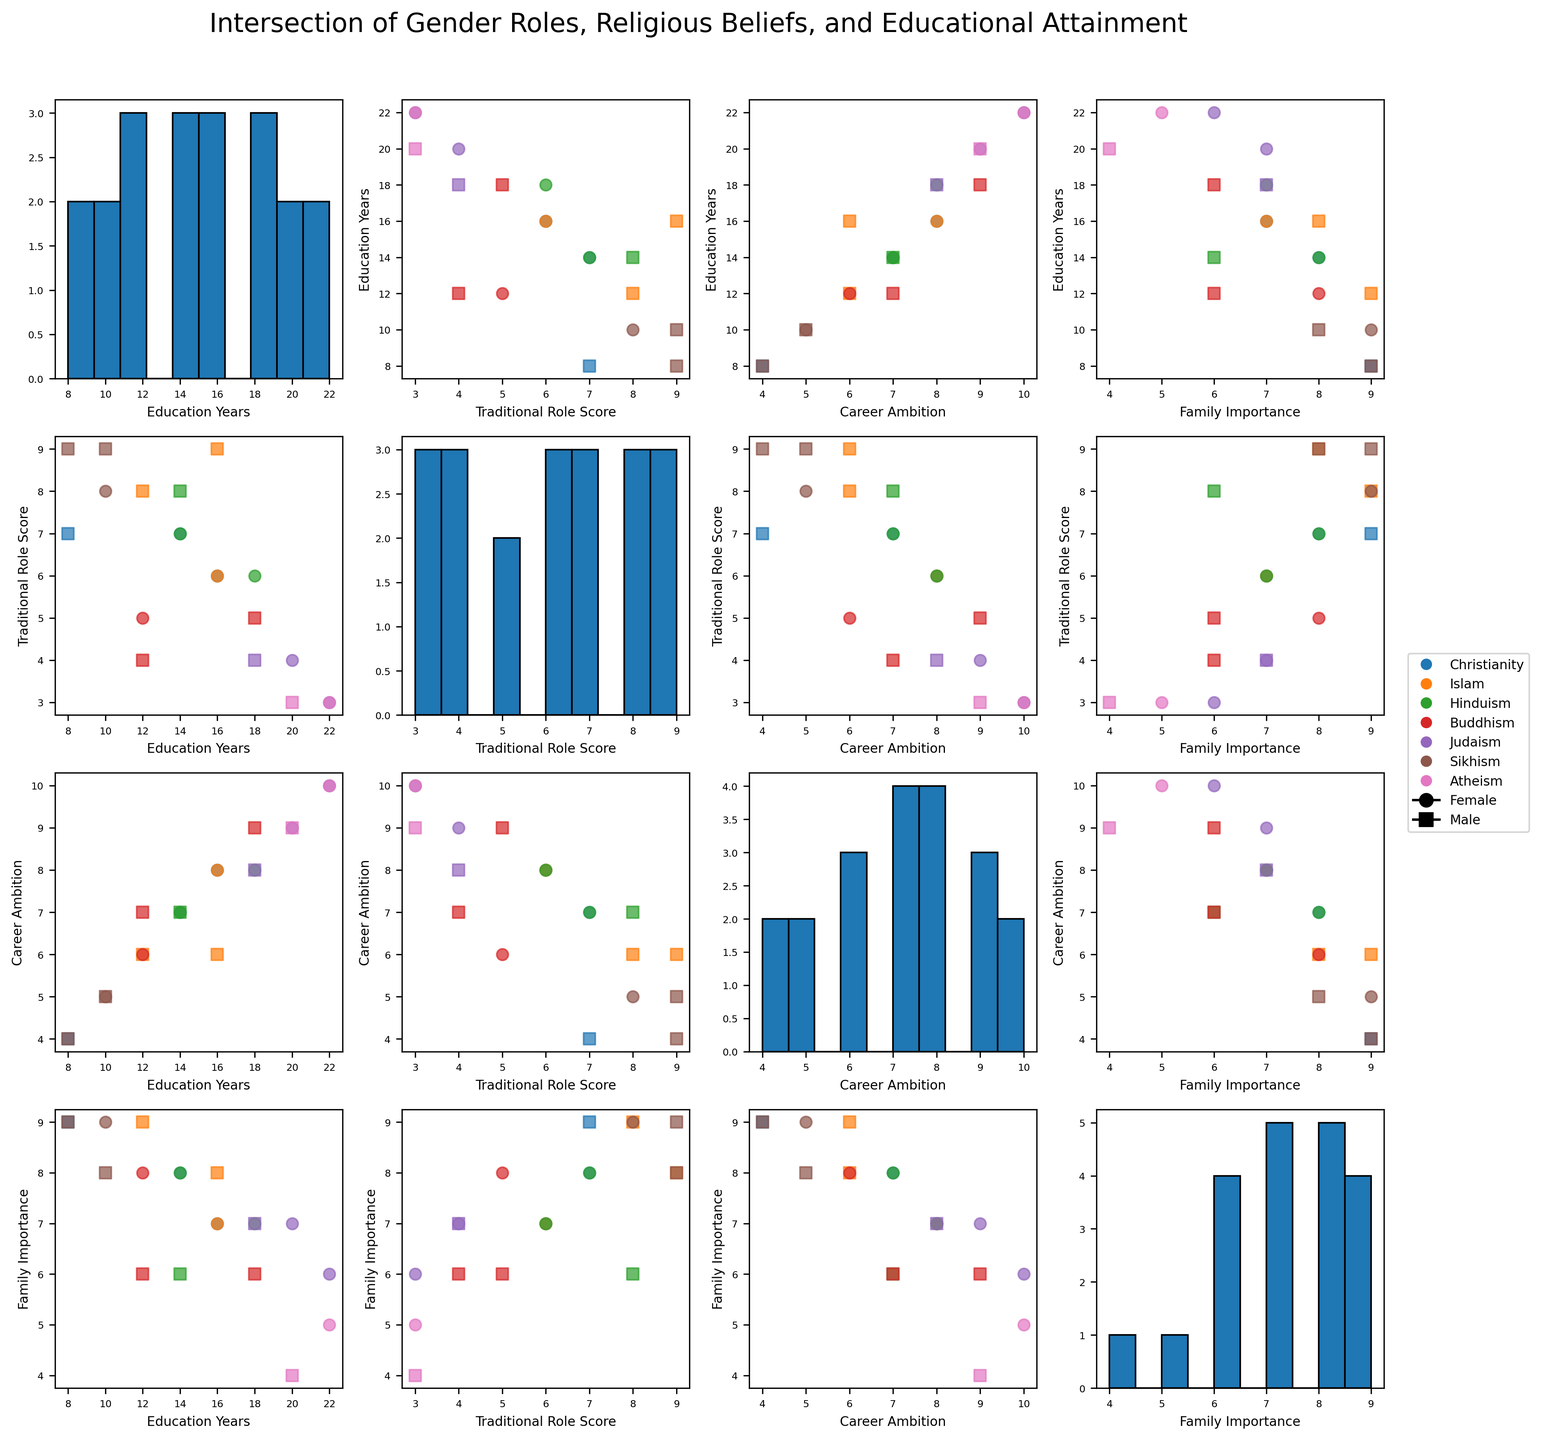What's the title of the figure? The title is usually displayed at the top of the figure. For this scatter plot matrix, it says "Intersection of Gender Roles, Religious Beliefs, and Educational Attainment".
Answer: Intersection of Gender Roles, Religious Beliefs, and Educational Attainment How many numeric variables are plotted in the scatter plot matrix? Look at the number of columns and rows in the scatter plot matrix; they should be equal to the number of numeric variables in the dataset. In this case, there are four numeric variables.
Answer: Four Which variable is used in both the x-axis and y-axis of the second column scatter plot? Locate the second column in the scatter plot matrix and see which variable is on the x-axis and y-axis for all scatter plots in that column. Here, it’s "Traditional Role Score".
Answer: Traditional Role Score What is the overall trend between 'Education Years' and 'Career Ambition'? Examine the scatter plots where 'Education Years' is on the y-axis and 'Career Ambition' is on the x-axis. Check if the points suggest a positive or negative relationship. The scatter plot should show a positive trend indicating that as Education Years increase, Career Ambition tends to increase.
Answer: Positive trend Which religion has the most diverse representation of both genders in 'Traditional Role Score' vs. 'Family Importance'? Identify the scatter plot for 'Traditional Role Score' on the y-axis and 'Family Importance' on the x-axis. Check the symbols and colors corresponding to each religion for diversity in scores. Sikhism appears to have a wide range of scores for both males and females.
Answer: Sikhism Are there more data points above or below the median 'Education Years' in the histogram? Locate the histogram for 'Education Years', identify the median value and observe if more data points are concentrated above or below this median. The histogram appears to have more data points below the median value of 16.
Answer: Below What is the average Traditional Role Score for males of different religions? Calculate the average of Traditional Role Score by summing the values for males across religions and dividing by the number of male data points. The scores for males are [8+5+9+7+8+4+9] = 50, divided by 7 (number of data points) is approximately 7.14.
Answer: Approximately 7.14 Which gender tends to have higher 'Family Importance'? Look at the scatter plots involving 'Family Importance' and observe the distribution of male and female data points. Females generally tend to have higher 'Family Importance', visible by the 'o' markers.
Answer: Females Which gender has a higher variation in 'Career Ambition'? In the scatter plots involving 'Career Ambition', compare the spread and clustering of 'o' markers (females) and 's' markers (males). Males tend to show a higher variation in 'Career Ambition'.
Answer: Males 